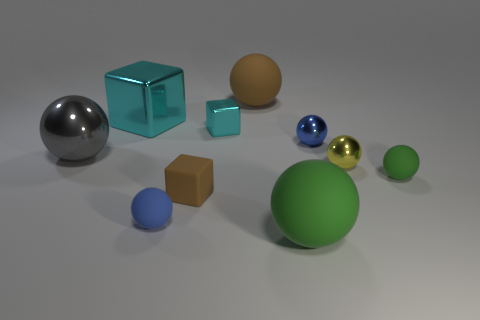Subtract all brown balls. How many balls are left? 6 Subtract all large green spheres. How many spheres are left? 6 Subtract all green balls. Subtract all green cylinders. How many balls are left? 5 Subtract all balls. How many objects are left? 3 Subtract all green matte spheres. Subtract all big green spheres. How many objects are left? 7 Add 2 yellow things. How many yellow things are left? 3 Add 9 tiny blue metal objects. How many tiny blue metal objects exist? 10 Subtract 1 brown blocks. How many objects are left? 9 